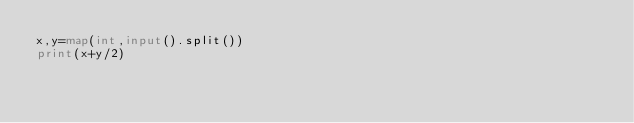Convert code to text. <code><loc_0><loc_0><loc_500><loc_500><_Python_>x,y=map(int,input().split())
print(x+y/2)</code> 